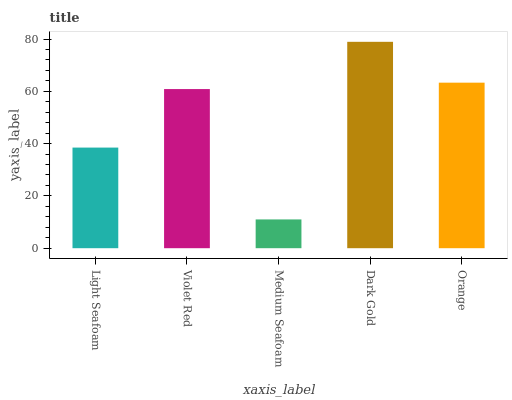Is Violet Red the minimum?
Answer yes or no. No. Is Violet Red the maximum?
Answer yes or no. No. Is Violet Red greater than Light Seafoam?
Answer yes or no. Yes. Is Light Seafoam less than Violet Red?
Answer yes or no. Yes. Is Light Seafoam greater than Violet Red?
Answer yes or no. No. Is Violet Red less than Light Seafoam?
Answer yes or no. No. Is Violet Red the high median?
Answer yes or no. Yes. Is Violet Red the low median?
Answer yes or no. Yes. Is Orange the high median?
Answer yes or no. No. Is Orange the low median?
Answer yes or no. No. 